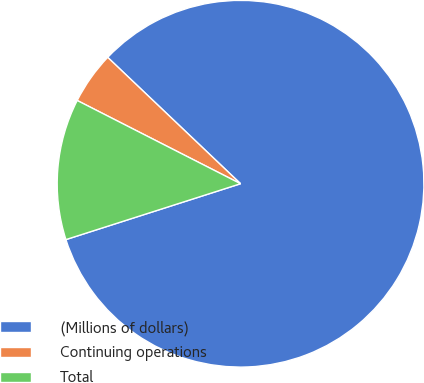<chart> <loc_0><loc_0><loc_500><loc_500><pie_chart><fcel>(Millions of dollars)<fcel>Continuing operations<fcel>Total<nl><fcel>82.97%<fcel>4.6%<fcel>12.43%<nl></chart> 